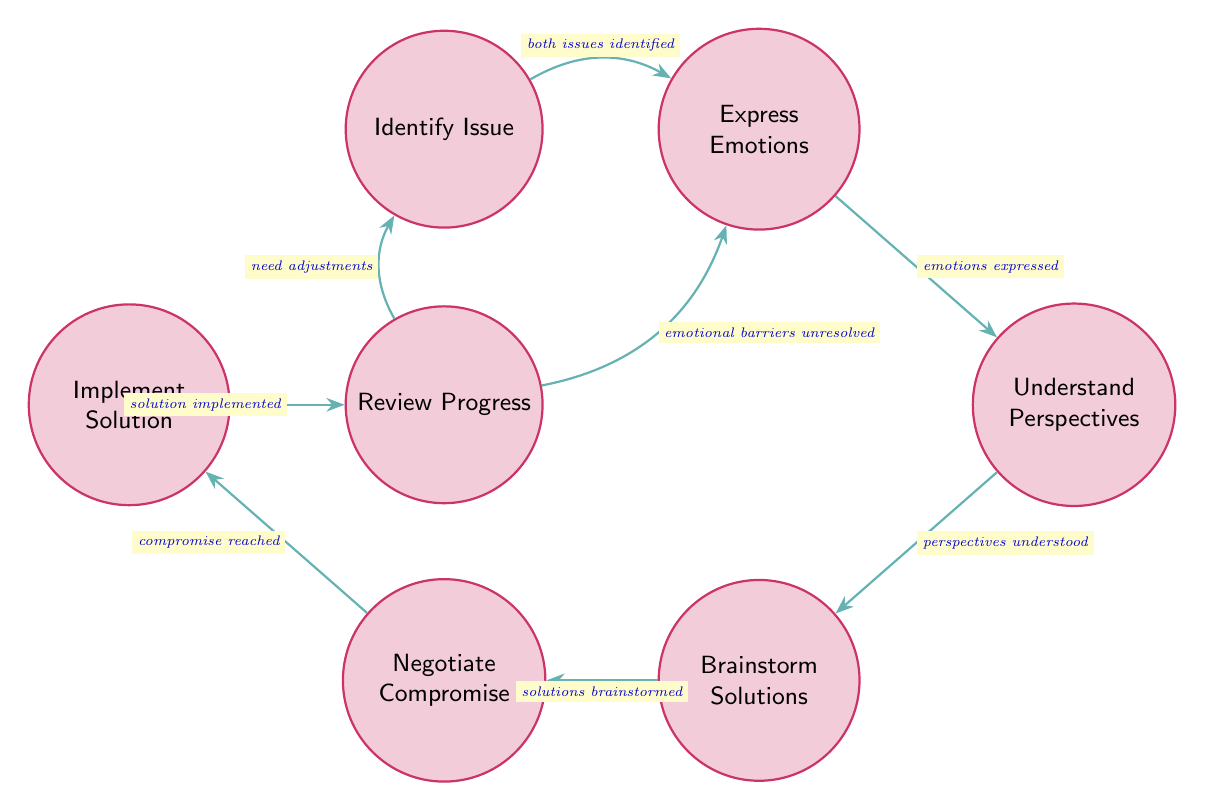What is the first state in the conflict resolution process? The diagram indicates that the first state is "Identify Issue," which is the starting point where both partners articulate their perceived issues without interruption.
Answer: Identify Issue How many nodes are in the diagram? By counting the states listed in the diagram, we can see there are seven distinct states, hence, the total number of nodes is 7.
Answer: 7 What action leads from "Implement Solution" to "Review Progress"? The action that leads from "Implement Solution" to "Review Progress" is "solution implemented," indicating that the couple has effectively implemented the solution.
Answer: solution implemented Which state follows after "Brainstorm Solutions"? The state that follows after "Brainstorm Solutions" is "Negotiate Compromise," as indicated by the directed transition from one state to the next in the sequence of conflict resolution stages.
Answer: Negotiate Compromise What action must occur after emotions are expressed? The action that must occur after emotions are expressed is "perspectives understood," where the therapist helps the couples to understand each other's viewpoints and feelings.
Answer: perspectives understood What are the two possible states following "Review Progress"? Two possible states after "Review Progress" are "Identify Issue" and "Express Emotions." This indicates that if adjustments are needed or if emotional barriers remain, the couple may cycle back to these respective stages for further work.
Answer: Identify Issue, Express Emotions What is the transition action from "Understand Perspectives" to "Brainstorm Solutions"? The transition action from "Understand Perspectives" to "Brainstorm Solutions" is "perspectives understood," which signifies that after understanding each other's perspectives, the couple can begin to brainstorm solutions collaboratively.
Answer: perspectives understood How many transitions are shown in the diagram? To find the number of transitions, we need to count the connections displayed in the diagram between the states. There are a total of 7 transitions connecting the states.
Answer: 7 What does the diagram suggest happens if "emotional barriers unresolved"? The diagram suggests that if there are "emotional barriers unresolved," the process leads back to "Express Emotions," indicating a need for further emotional exploration before moving forward in the resolution process.
Answer: Express Emotions 